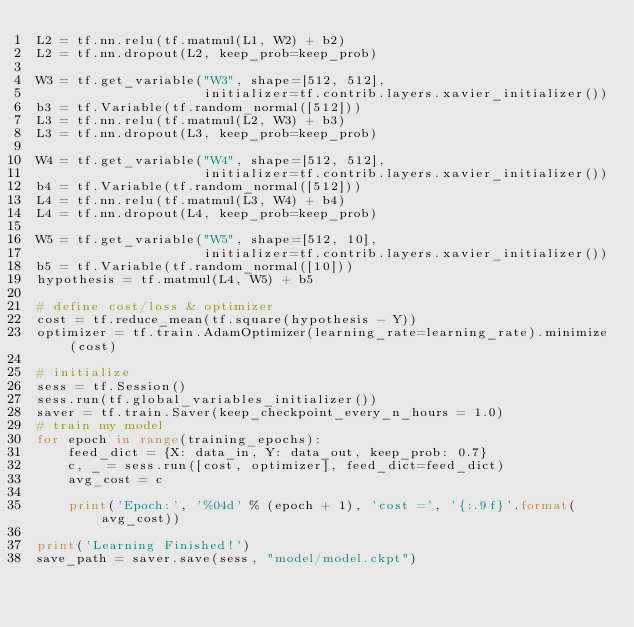<code> <loc_0><loc_0><loc_500><loc_500><_Python_>L2 = tf.nn.relu(tf.matmul(L1, W2) + b2)
L2 = tf.nn.dropout(L2, keep_prob=keep_prob)

W3 = tf.get_variable("W3", shape=[512, 512],
                     initializer=tf.contrib.layers.xavier_initializer())
b3 = tf.Variable(tf.random_normal([512]))
L3 = tf.nn.relu(tf.matmul(L2, W3) + b3)
L3 = tf.nn.dropout(L3, keep_prob=keep_prob)

W4 = tf.get_variable("W4", shape=[512, 512],
                     initializer=tf.contrib.layers.xavier_initializer())
b4 = tf.Variable(tf.random_normal([512]))
L4 = tf.nn.relu(tf.matmul(L3, W4) + b4)
L4 = tf.nn.dropout(L4, keep_prob=keep_prob)

W5 = tf.get_variable("W5", shape=[512, 10],
                     initializer=tf.contrib.layers.xavier_initializer())
b5 = tf.Variable(tf.random_normal([10]))
hypothesis = tf.matmul(L4, W5) + b5

# define cost/loss & optimizer
cost = tf.reduce_mean(tf.square(hypothesis - Y))
optimizer = tf.train.AdamOptimizer(learning_rate=learning_rate).minimize(cost)

# initialize
sess = tf.Session()
sess.run(tf.global_variables_initializer())
saver = tf.train.Saver(keep_checkpoint_every_n_hours = 1.0)
# train my model
for epoch in range(training_epochs):
    feed_dict = {X: data_in, Y: data_out, keep_prob: 0.7}
    c, _ = sess.run([cost, optimizer], feed_dict=feed_dict)
    avg_cost = c

    print('Epoch:', '%04d' % (epoch + 1), 'cost =', '{:.9f}'.format(avg_cost))

print('Learning Finished!')
save_path = saver.save(sess, "model/model.ckpt")</code> 